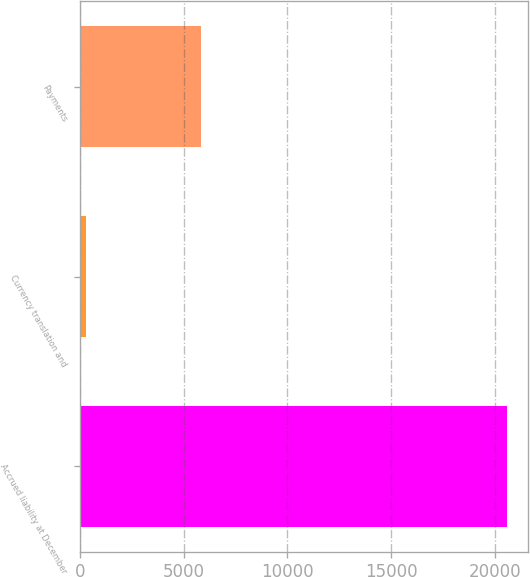Convert chart to OTSL. <chart><loc_0><loc_0><loc_500><loc_500><bar_chart><fcel>Accrued liability at December<fcel>Currency translation and<fcel>Payments<nl><fcel>20595<fcel>284<fcel>5849<nl></chart> 